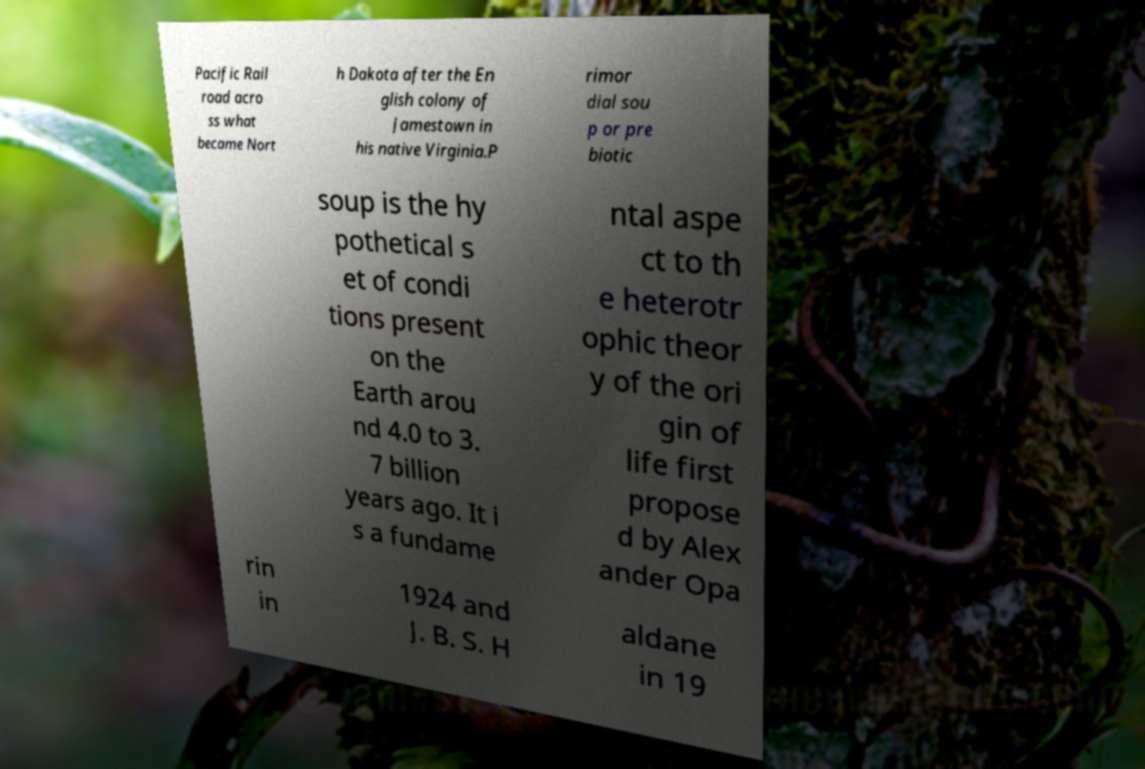Can you accurately transcribe the text from the provided image for me? Pacific Rail road acro ss what became Nort h Dakota after the En glish colony of Jamestown in his native Virginia.P rimor dial sou p or pre biotic soup is the hy pothetical s et of condi tions present on the Earth arou nd 4.0 to 3. 7 billion years ago. It i s a fundame ntal aspe ct to th e heterotr ophic theor y of the ori gin of life first propose d by Alex ander Opa rin in 1924 and J. B. S. H aldane in 19 